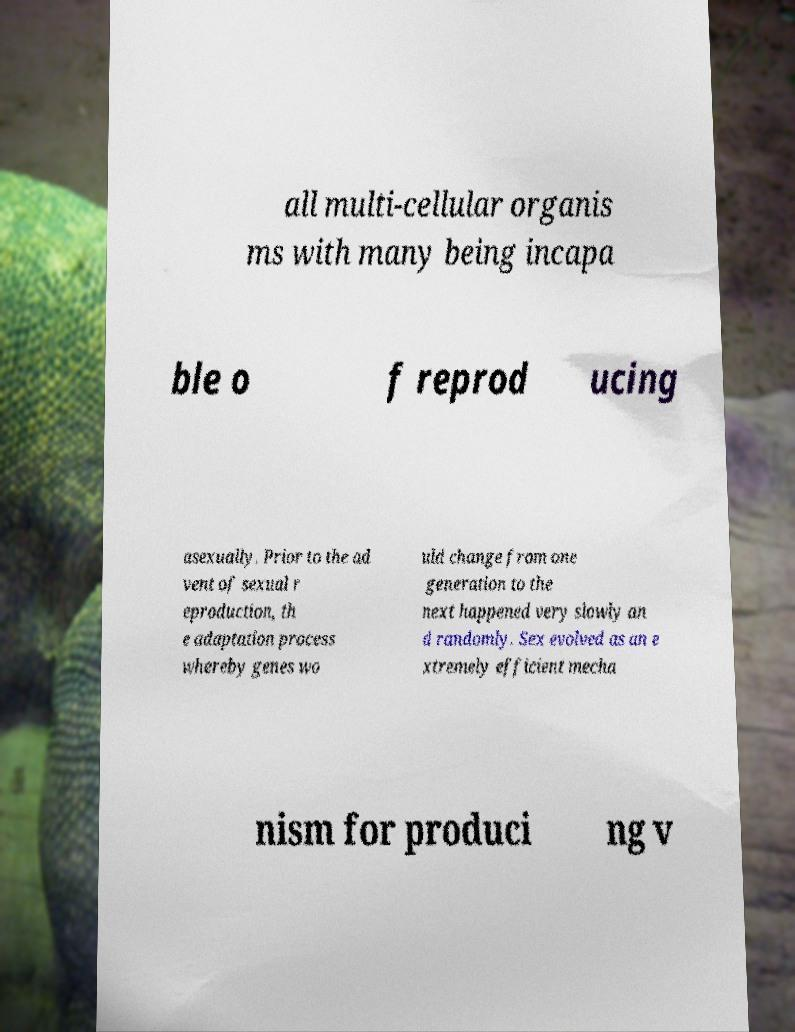Please read and relay the text visible in this image. What does it say? all multi-cellular organis ms with many being incapa ble o f reprod ucing asexually. Prior to the ad vent of sexual r eproduction, th e adaptation process whereby genes wo uld change from one generation to the next happened very slowly an d randomly. Sex evolved as an e xtremely efficient mecha nism for produci ng v 